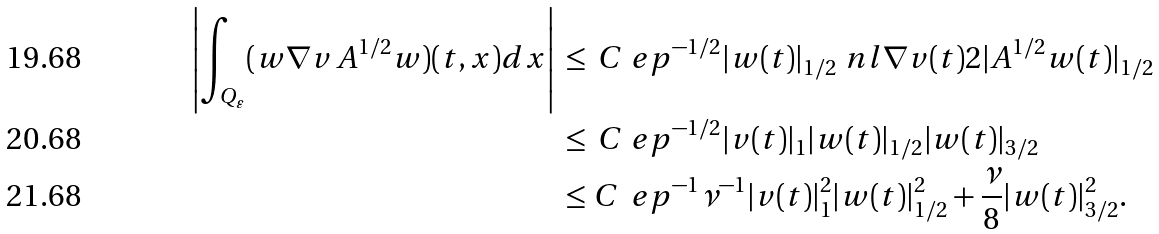<formula> <loc_0><loc_0><loc_500><loc_500>\left | \int _ { Q _ { \varepsilon } } ( w \nabla v \, A ^ { 1 / 2 } w ) ( t , x ) d x \right | & \, \leq \, C \ e p ^ { - 1 / 2 } | w ( t ) | _ { 1 / 2 } \ n l { \nabla v ( t ) } { 2 } | A ^ { 1 / 2 } w ( t ) | _ { 1 / 2 } \\ & \, \leq \, C \ e p ^ { - 1 / 2 } | v ( t ) | _ { 1 } | w ( t ) | _ { 1 / 2 } | w ( t ) | _ { 3 / 2 } \\ & \, \leq C \, \ e p ^ { - 1 } \nu ^ { - 1 } | v ( t ) | _ { 1 } ^ { 2 } | w ( t ) | _ { 1 / 2 } ^ { 2 } + \frac { \nu } { 8 } | w ( t ) | _ { 3 / 2 } ^ { 2 } .</formula> 